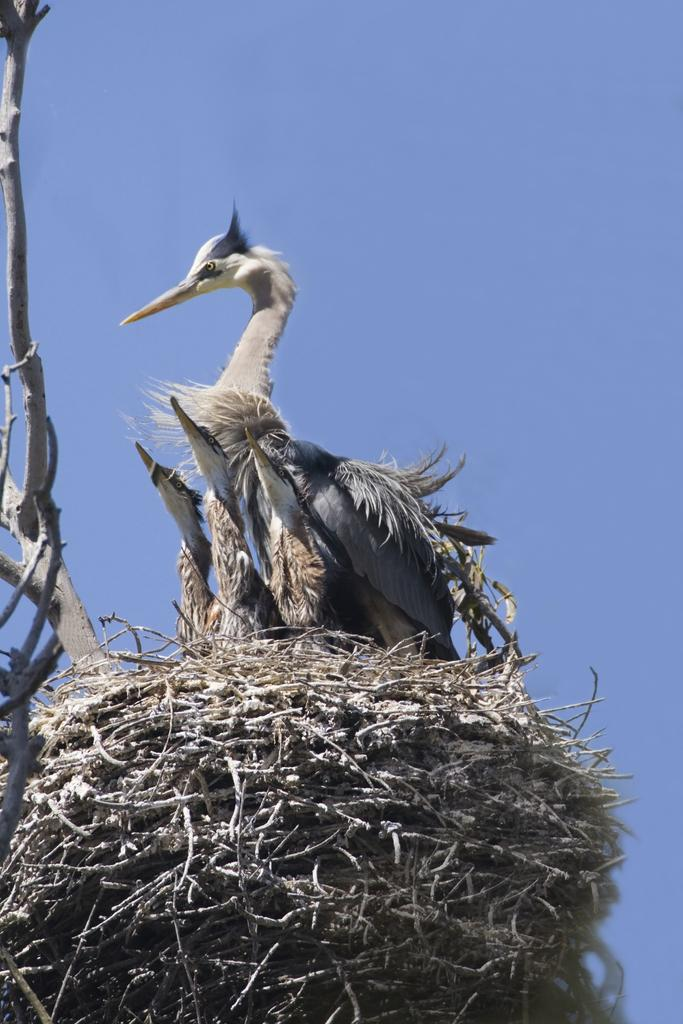What is located on the tree in the image? There is a bird nest on a tree in the image. What type of animals can be seen in the image? There are birds in the image. What colors are present on the birds? The birds have brown, cream, black, and white colors. What can be seen in the background of the image? The sky is visible in the background of the image. Where is the faucet located in the image? There is no faucet present in the image. What type of meat can be seen hanging from the tree in the image? There is no meat present in the image; it features a bird nest and birds. 